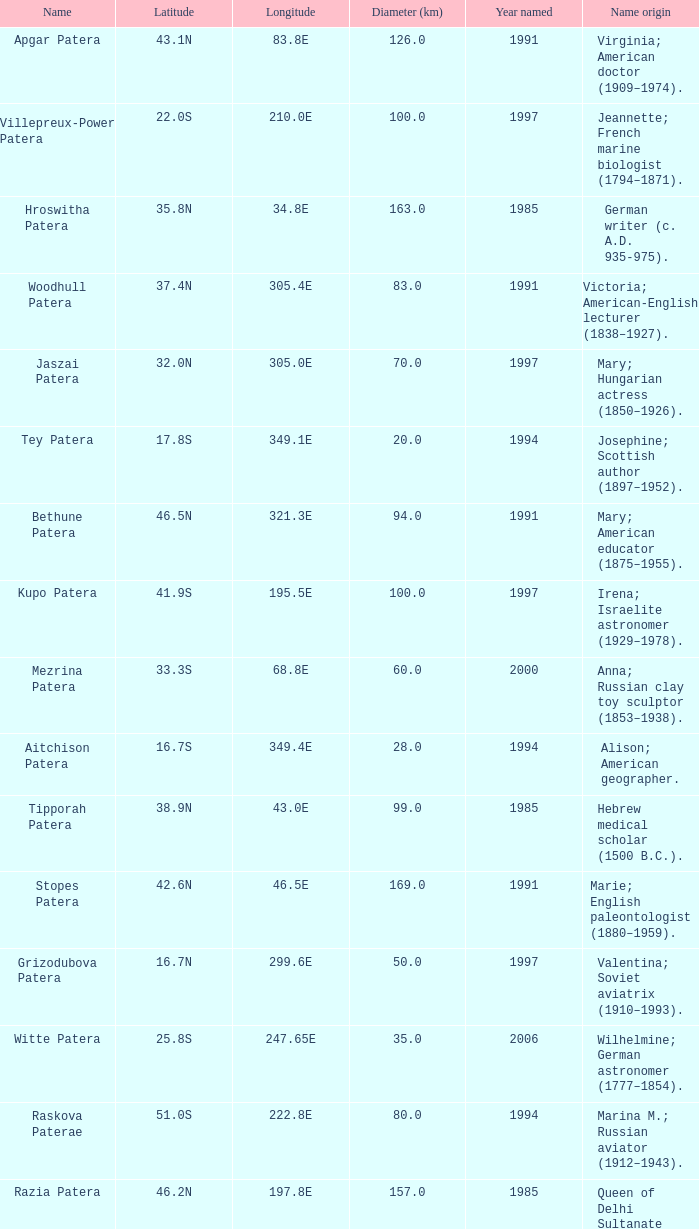What is the diameter in km of the feature named Colette Patera?  149.0. 